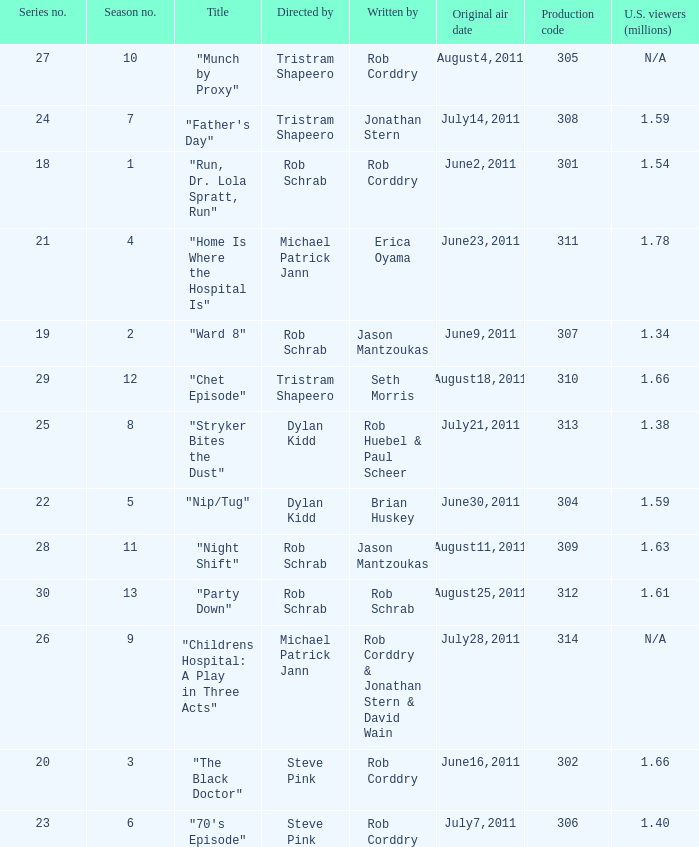At most what number in the series was the episode "chet episode"? 29.0. 